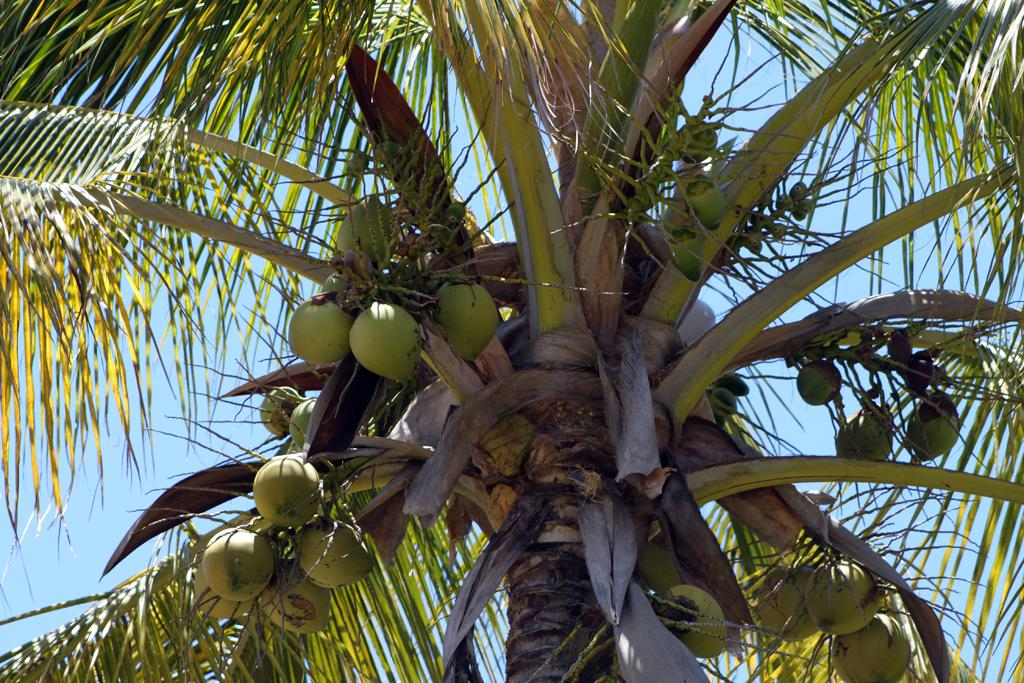What type of tree is present in the image? There is a tree with coconuts in the image. What can be seen in the background of the image? The sky is visible in the background of the image. What type of insurance policy is being discussed in the image? There is no indication in the image of any discussion about insurance policies. 